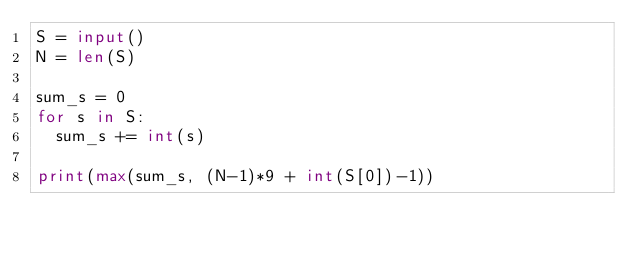Convert code to text. <code><loc_0><loc_0><loc_500><loc_500><_Python_>S = input()
N = len(S)

sum_s = 0
for s in S:
  sum_s += int(s)

print(max(sum_s, (N-1)*9 + int(S[0])-1))</code> 